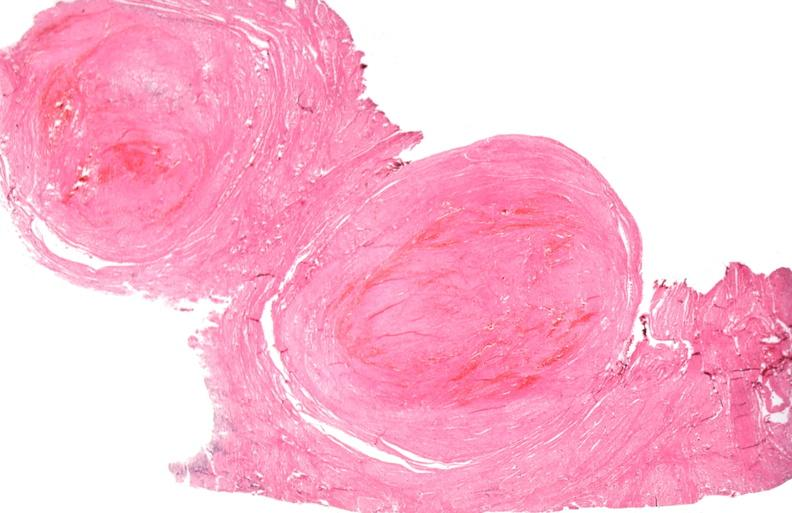what does this image show?
Answer the question using a single word or phrase. Uterus 